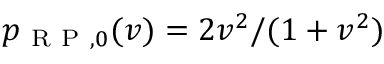<formula> <loc_0><loc_0><loc_500><loc_500>p _ { R P , 0 } ( v ) = 2 v ^ { 2 } / ( 1 + v ^ { 2 } )</formula> 